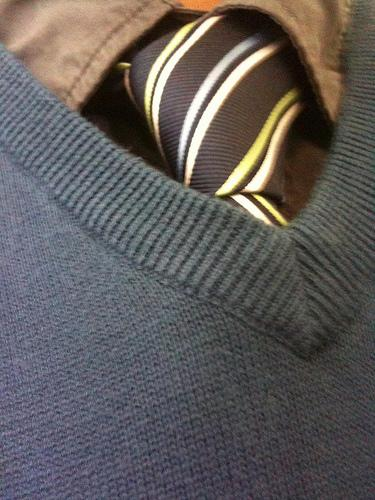Using the object interaction information given, describe a high-level understanding of the scene. A person is wearing a v-neck blue sweater with intricate knitting patterns and a tie with a brown knot and various stripes, positioned under a grey collar. Identify the main garment worn by the person in the image. A v-neck blue sweater with a tie. Based on the provided information, what type of knot is used on the tie? The knot on the tie is a Windsor knot. What emotions or sentiment do you think the image is conveying?  The image conveys a sophisticated and well-dressed sentiment. Count the number of objects mentioned in the captions associated with physical details on the sweater. There are 19 objects associated with physical details on the sweater. Describe the texture and patterns of the sweater worn in the image. The sweater has a tight knitting with blue fibers and patterns of blue knitting on it. How many objects explicitly mentioned in the captions are related to the tie? There are 12 objects related to the tie. What is the dominant color of the tie knot according to the image? The dominant color of the tie knot is brown. Rate the image quality according to the provided information on a scale of 1 to 10. Considering the detailed nature of the bounding boxes provided, I would rate the image quality at an 8. Examine the image and provide a brief description of the collar. The collar is grey, stitching is visible, and it has a right-side portion. What color is the tie knot in the image? Blue, yellow, and brown Identify the main color of the sweater in the image. Blue Can you find the red polka dots on the tie, and note their position? The tie in the image is described as being mostly black with white, green, and blue stripes, but there is no mention of red polka dots. What is the activity or action of the person wearing the clothing items in the image? Not applicable, as there is no clear activity or action visible Does the tie have a clip or pin? If yes, what does it look like and where is it positioned? No, it's not mentioned in the image. List the colors of the fibers in the tie. Black, white, green, and blue Based on the clothing items, what might be the occasion or event? A casual or semi-formal gathering What type of knot is used in the tie? Windsor knot How would you describe the appearance of the collar in relation to the knot of the tie? The collar is grey and sits under the tie knot Create a marketing tagline for a clothing brand based on the image. "Define your style with elegance and comfort." Analyze the sweater's knitting pattern and describe it. Tight blue knitting with some visible gaps What type of knot is present in the tie from the options below: double Windsor, half-Windsor, four-in-hand, and Pratt? Cannot determine from the options provided Describe the texture of the sweater fabric in the image. Tightly knitted blue fabric with some visible gaps Identify the type of clothing the tie is worn over. A V-neck blue sweater Determine the feeling or emotion displayed by a person wearing the clothing items. Not applicable, as there is no facial expression visible Describe the size of the visible part of the tie under the knot. Small Describe the pattern on the tie. Stripes of white, green, blue, and black Are there any patterns on the sweater? Yes, some patterns are visible in the knitting For the following emotions, choose whether they apply to the person wearing the clothing: joyful, angry, neutral, sad. Cannot determine, as there is no facial expression visible How does the collar on the shirt appear in the image? Grey and right side has stitching Based on the image, where is the tie knot in relation to the sweater? Over the blue sweater Is there any diagram in the image? No 